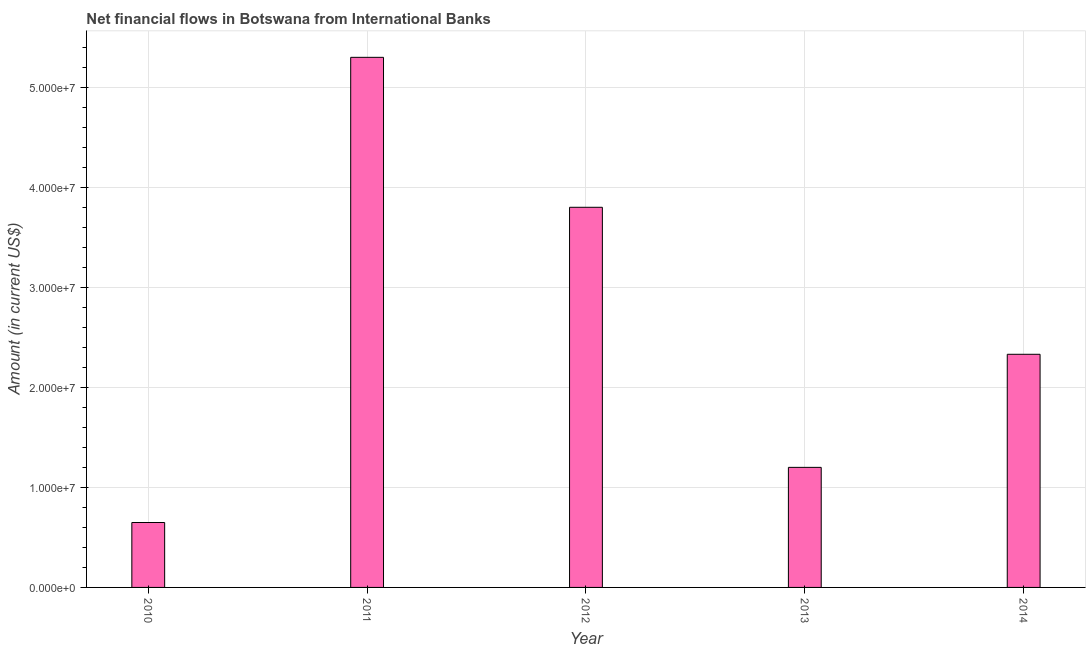Does the graph contain any zero values?
Provide a succinct answer. No. What is the title of the graph?
Your answer should be compact. Net financial flows in Botswana from International Banks. What is the label or title of the X-axis?
Give a very brief answer. Year. What is the net financial flows from ibrd in 2011?
Your answer should be compact. 5.30e+07. Across all years, what is the maximum net financial flows from ibrd?
Ensure brevity in your answer.  5.30e+07. Across all years, what is the minimum net financial flows from ibrd?
Provide a short and direct response. 6.49e+06. In which year was the net financial flows from ibrd minimum?
Offer a terse response. 2010. What is the sum of the net financial flows from ibrd?
Offer a very short reply. 1.33e+08. What is the difference between the net financial flows from ibrd in 2010 and 2013?
Offer a very short reply. -5.51e+06. What is the average net financial flows from ibrd per year?
Make the answer very short. 2.66e+07. What is the median net financial flows from ibrd?
Offer a very short reply. 2.33e+07. What is the ratio of the net financial flows from ibrd in 2011 to that in 2012?
Make the answer very short. 1.4. Is the net financial flows from ibrd in 2013 less than that in 2014?
Your response must be concise. Yes. Is the difference between the net financial flows from ibrd in 2011 and 2013 greater than the difference between any two years?
Provide a short and direct response. No. What is the difference between the highest and the second highest net financial flows from ibrd?
Your answer should be compact. 1.50e+07. What is the difference between the highest and the lowest net financial flows from ibrd?
Keep it short and to the point. 4.65e+07. In how many years, is the net financial flows from ibrd greater than the average net financial flows from ibrd taken over all years?
Your response must be concise. 2. What is the Amount (in current US$) in 2010?
Your answer should be compact. 6.49e+06. What is the Amount (in current US$) in 2011?
Offer a very short reply. 5.30e+07. What is the Amount (in current US$) of 2012?
Make the answer very short. 3.80e+07. What is the Amount (in current US$) of 2013?
Offer a very short reply. 1.20e+07. What is the Amount (in current US$) in 2014?
Give a very brief answer. 2.33e+07. What is the difference between the Amount (in current US$) in 2010 and 2011?
Ensure brevity in your answer.  -4.65e+07. What is the difference between the Amount (in current US$) in 2010 and 2012?
Provide a short and direct response. -3.15e+07. What is the difference between the Amount (in current US$) in 2010 and 2013?
Provide a short and direct response. -5.51e+06. What is the difference between the Amount (in current US$) in 2010 and 2014?
Provide a short and direct response. -1.68e+07. What is the difference between the Amount (in current US$) in 2011 and 2012?
Provide a short and direct response. 1.50e+07. What is the difference between the Amount (in current US$) in 2011 and 2013?
Your answer should be compact. 4.10e+07. What is the difference between the Amount (in current US$) in 2011 and 2014?
Provide a short and direct response. 2.97e+07. What is the difference between the Amount (in current US$) in 2012 and 2013?
Keep it short and to the point. 2.60e+07. What is the difference between the Amount (in current US$) in 2012 and 2014?
Your response must be concise. 1.47e+07. What is the difference between the Amount (in current US$) in 2013 and 2014?
Make the answer very short. -1.13e+07. What is the ratio of the Amount (in current US$) in 2010 to that in 2011?
Ensure brevity in your answer.  0.12. What is the ratio of the Amount (in current US$) in 2010 to that in 2012?
Your response must be concise. 0.17. What is the ratio of the Amount (in current US$) in 2010 to that in 2013?
Your answer should be compact. 0.54. What is the ratio of the Amount (in current US$) in 2010 to that in 2014?
Your response must be concise. 0.28. What is the ratio of the Amount (in current US$) in 2011 to that in 2012?
Offer a very short reply. 1.4. What is the ratio of the Amount (in current US$) in 2011 to that in 2013?
Offer a very short reply. 4.42. What is the ratio of the Amount (in current US$) in 2011 to that in 2014?
Your answer should be very brief. 2.27. What is the ratio of the Amount (in current US$) in 2012 to that in 2013?
Give a very brief answer. 3.17. What is the ratio of the Amount (in current US$) in 2012 to that in 2014?
Make the answer very short. 1.63. What is the ratio of the Amount (in current US$) in 2013 to that in 2014?
Your answer should be compact. 0.52. 